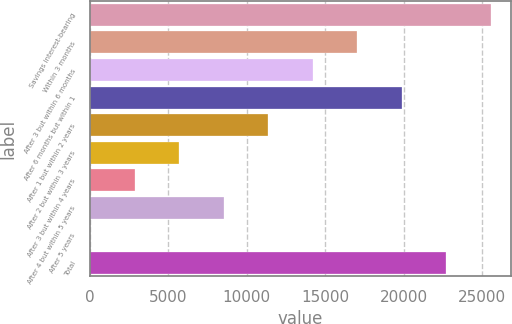Convert chart to OTSL. <chart><loc_0><loc_0><loc_500><loc_500><bar_chart><fcel>Savings interest-bearing<fcel>Within 3 months<fcel>After 3 but within 6 months<fcel>After 6 months but within 1<fcel>After 1 but within 2 years<fcel>After 2 but within 3 years<fcel>After 3 but within 4 years<fcel>After 4 but within 5 years<fcel>After 5 years<fcel>Total<nl><fcel>25575.7<fcel>17050.6<fcel>14208.9<fcel>19892.3<fcel>11367.1<fcel>5683.72<fcel>2842.01<fcel>8525.43<fcel>0.3<fcel>22734<nl></chart> 